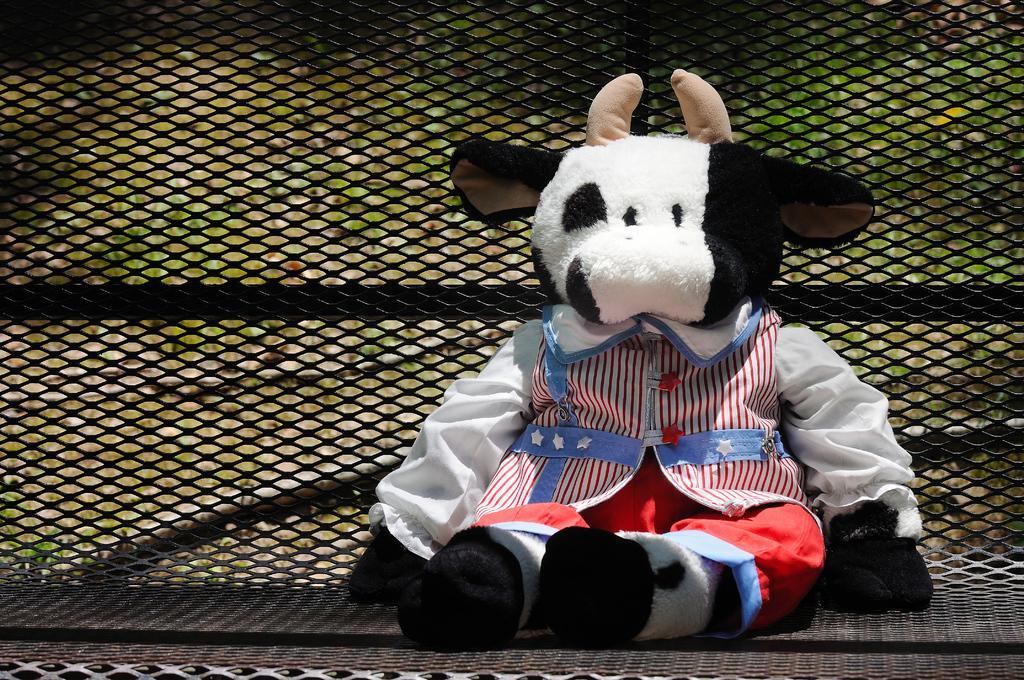In one or two sentences, can you explain what this image depicts? In the center of the image there is a toy. In the background of the image there is grill. 